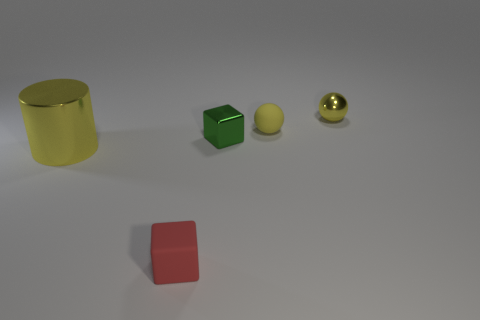What number of tiny yellow balls are both left of the tiny yellow shiny sphere and on the right side of the rubber sphere?
Your answer should be very brief. 0. The tiny shiny object that is in front of the small object behind the small rubber object behind the large yellow shiny cylinder is what color?
Your answer should be compact. Green. What number of small red things are behind the tiny rubber ball behind the tiny matte cube?
Your response must be concise. 0. How many other objects are there of the same shape as the big yellow shiny thing?
Make the answer very short. 0. What number of objects are either big gray things or things on the right side of the matte sphere?
Make the answer very short. 1. Are there more large shiny cylinders to the right of the tiny yellow matte ball than shiny things that are left of the tiny green block?
Your answer should be compact. No. The small thing that is in front of the yellow object left of the small matte thing on the right side of the red block is what shape?
Provide a short and direct response. Cube. The tiny object in front of the shiny object that is to the left of the small red rubber cube is what shape?
Provide a succinct answer. Cube. Is there a big cyan sphere made of the same material as the green block?
Your response must be concise. No. There is a matte ball that is the same color as the tiny metal ball; what is its size?
Make the answer very short. Small. 